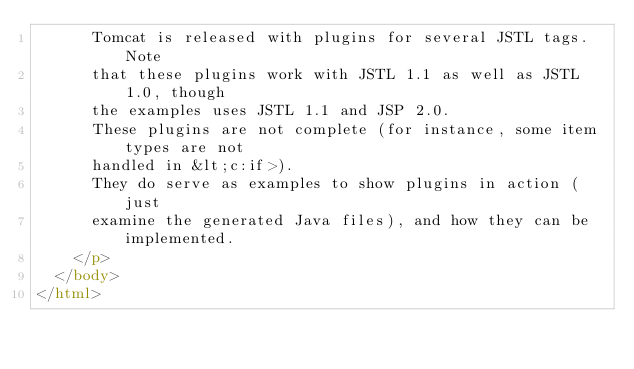<code> <loc_0><loc_0><loc_500><loc_500><_HTML_>      Tomcat is released with plugins for several JSTL tags.  Note
      that these plugins work with JSTL 1.1 as well as JSTL 1.0, though
      the examples uses JSTL 1.1 and JSP 2.0.
      These plugins are not complete (for instance, some item types are not
      handled in &lt;c:if>).
      They do serve as examples to show plugins in action (just
      examine the generated Java files), and how they can be implemented.
    </p>
  </body>
</html>

</code> 